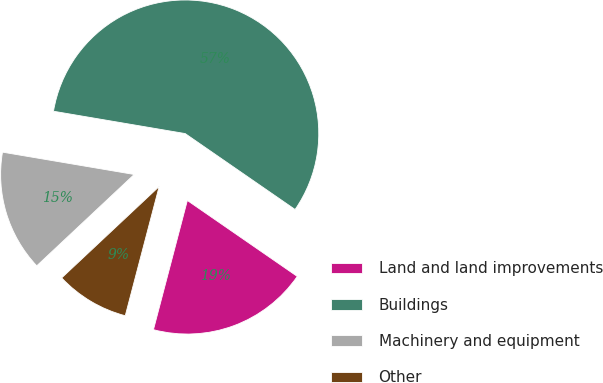Convert chart. <chart><loc_0><loc_0><loc_500><loc_500><pie_chart><fcel>Land and land improvements<fcel>Buildings<fcel>Machinery and equipment<fcel>Other<nl><fcel>19.46%<fcel>56.95%<fcel>14.66%<fcel>8.93%<nl></chart> 